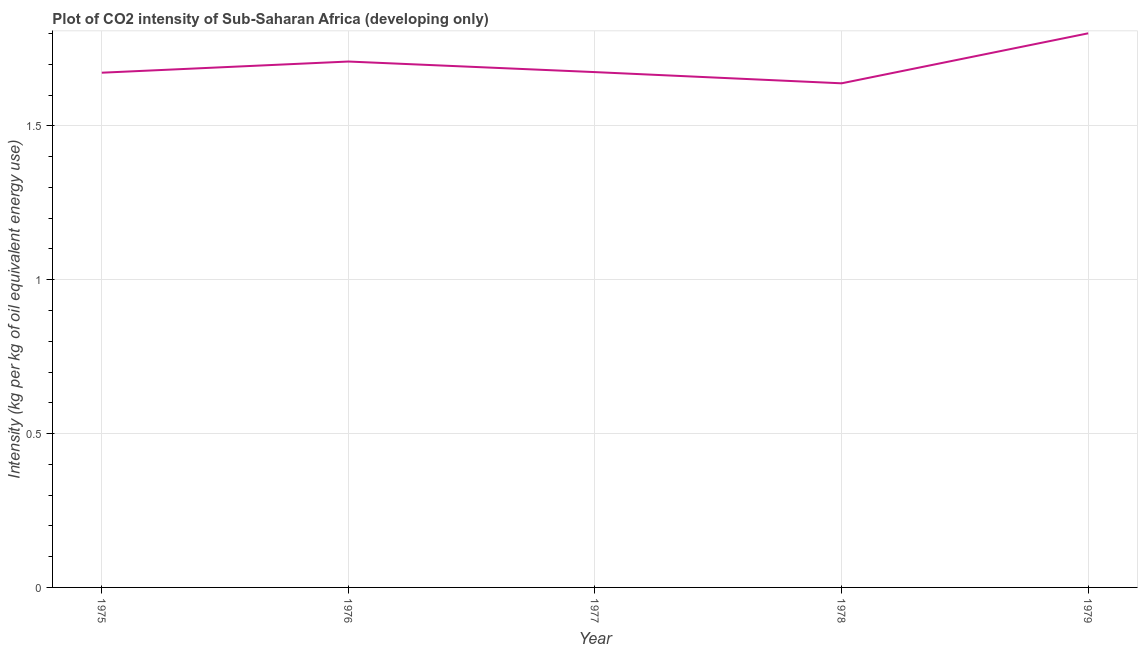What is the co2 intensity in 1976?
Make the answer very short. 1.71. Across all years, what is the maximum co2 intensity?
Keep it short and to the point. 1.8. Across all years, what is the minimum co2 intensity?
Keep it short and to the point. 1.64. In which year was the co2 intensity maximum?
Give a very brief answer. 1979. In which year was the co2 intensity minimum?
Provide a succinct answer. 1978. What is the sum of the co2 intensity?
Offer a terse response. 8.5. What is the difference between the co2 intensity in 1976 and 1979?
Provide a short and direct response. -0.09. What is the average co2 intensity per year?
Offer a terse response. 1.7. What is the median co2 intensity?
Provide a short and direct response. 1.67. Do a majority of the years between 1975 and 1976 (inclusive) have co2 intensity greater than 1.2 kg?
Offer a very short reply. Yes. What is the ratio of the co2 intensity in 1975 to that in 1978?
Ensure brevity in your answer.  1.02. Is the co2 intensity in 1978 less than that in 1979?
Keep it short and to the point. Yes. Is the difference between the co2 intensity in 1976 and 1979 greater than the difference between any two years?
Provide a short and direct response. No. What is the difference between the highest and the second highest co2 intensity?
Your response must be concise. 0.09. What is the difference between the highest and the lowest co2 intensity?
Provide a succinct answer. 0.16. Does the co2 intensity monotonically increase over the years?
Ensure brevity in your answer.  No. What is the difference between two consecutive major ticks on the Y-axis?
Your answer should be compact. 0.5. What is the title of the graph?
Keep it short and to the point. Plot of CO2 intensity of Sub-Saharan Africa (developing only). What is the label or title of the X-axis?
Offer a very short reply. Year. What is the label or title of the Y-axis?
Offer a very short reply. Intensity (kg per kg of oil equivalent energy use). What is the Intensity (kg per kg of oil equivalent energy use) of 1975?
Keep it short and to the point. 1.67. What is the Intensity (kg per kg of oil equivalent energy use) of 1976?
Give a very brief answer. 1.71. What is the Intensity (kg per kg of oil equivalent energy use) of 1977?
Your answer should be very brief. 1.67. What is the Intensity (kg per kg of oil equivalent energy use) in 1978?
Ensure brevity in your answer.  1.64. What is the Intensity (kg per kg of oil equivalent energy use) of 1979?
Your response must be concise. 1.8. What is the difference between the Intensity (kg per kg of oil equivalent energy use) in 1975 and 1976?
Make the answer very short. -0.04. What is the difference between the Intensity (kg per kg of oil equivalent energy use) in 1975 and 1977?
Your answer should be compact. -0. What is the difference between the Intensity (kg per kg of oil equivalent energy use) in 1975 and 1978?
Provide a short and direct response. 0.03. What is the difference between the Intensity (kg per kg of oil equivalent energy use) in 1975 and 1979?
Provide a succinct answer. -0.13. What is the difference between the Intensity (kg per kg of oil equivalent energy use) in 1976 and 1977?
Your answer should be compact. 0.03. What is the difference between the Intensity (kg per kg of oil equivalent energy use) in 1976 and 1978?
Your answer should be very brief. 0.07. What is the difference between the Intensity (kg per kg of oil equivalent energy use) in 1976 and 1979?
Your answer should be very brief. -0.09. What is the difference between the Intensity (kg per kg of oil equivalent energy use) in 1977 and 1978?
Provide a short and direct response. 0.04. What is the difference between the Intensity (kg per kg of oil equivalent energy use) in 1977 and 1979?
Provide a succinct answer. -0.13. What is the difference between the Intensity (kg per kg of oil equivalent energy use) in 1978 and 1979?
Your response must be concise. -0.16. What is the ratio of the Intensity (kg per kg of oil equivalent energy use) in 1975 to that in 1976?
Offer a terse response. 0.98. What is the ratio of the Intensity (kg per kg of oil equivalent energy use) in 1975 to that in 1978?
Offer a very short reply. 1.02. What is the ratio of the Intensity (kg per kg of oil equivalent energy use) in 1975 to that in 1979?
Your answer should be very brief. 0.93. What is the ratio of the Intensity (kg per kg of oil equivalent energy use) in 1976 to that in 1977?
Your response must be concise. 1.02. What is the ratio of the Intensity (kg per kg of oil equivalent energy use) in 1976 to that in 1978?
Your answer should be compact. 1.04. What is the ratio of the Intensity (kg per kg of oil equivalent energy use) in 1976 to that in 1979?
Your answer should be very brief. 0.95. What is the ratio of the Intensity (kg per kg of oil equivalent energy use) in 1978 to that in 1979?
Your answer should be compact. 0.91. 